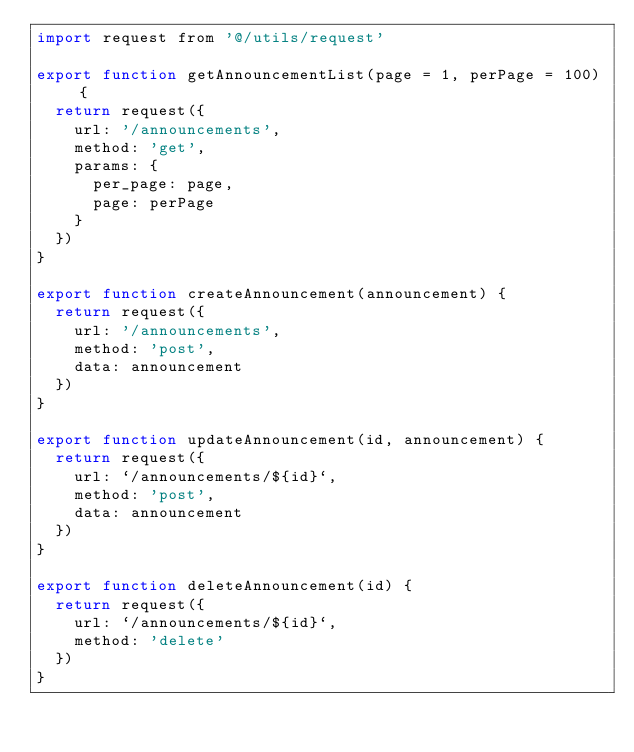Convert code to text. <code><loc_0><loc_0><loc_500><loc_500><_JavaScript_>import request from '@/utils/request'

export function getAnnouncementList(page = 1, perPage = 100) {
  return request({
    url: '/announcements',
    method: 'get',
    params: {
      per_page: page,
      page: perPage
    }
  })
}

export function createAnnouncement(announcement) {
  return request({
    url: '/announcements',
    method: 'post',
    data: announcement
  })
}

export function updateAnnouncement(id, announcement) {
  return request({
    url: `/announcements/${id}`,
    method: 'post',
    data: announcement
  })
}

export function deleteAnnouncement(id) {
  return request({
    url: `/announcements/${id}`,
    method: 'delete'
  })
}
</code> 